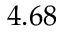<formula> <loc_0><loc_0><loc_500><loc_500>4 . 6 8</formula> 